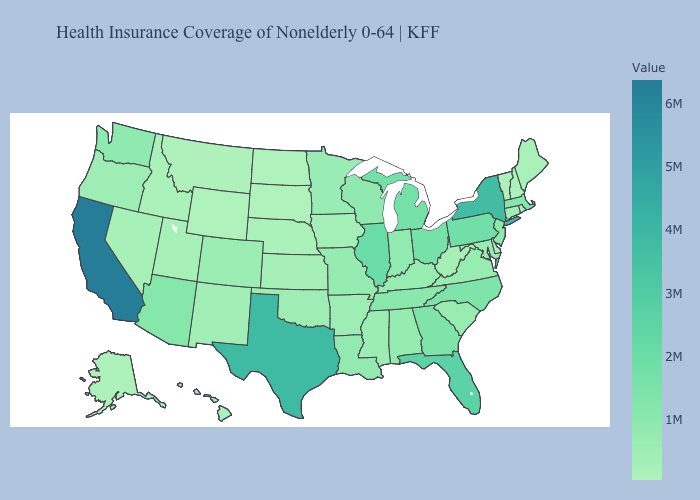Does the map have missing data?
Give a very brief answer. No. Does North Dakota have the lowest value in the MidWest?
Write a very short answer. Yes. Is the legend a continuous bar?
Write a very short answer. Yes. Does Colorado have the highest value in the USA?
Be succinct. No. Which states have the lowest value in the USA?
Quick response, please. Wyoming. Which states have the highest value in the USA?
Quick response, please. California. Does Connecticut have the highest value in the Northeast?
Concise answer only. No. 